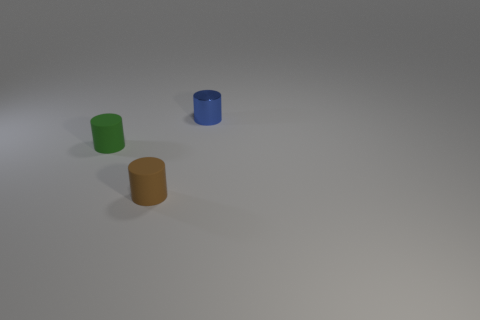Add 2 green cylinders. How many objects exist? 5 Subtract all small rubber cylinders. How many cylinders are left? 1 Subtract all brown cylinders. How many cylinders are left? 2 Subtract 1 cylinders. How many cylinders are left? 2 Subtract all purple cylinders. Subtract all cyan spheres. How many cylinders are left? 3 Subtract all brown cubes. How many brown cylinders are left? 1 Subtract all small shiny things. Subtract all big blue balls. How many objects are left? 2 Add 1 small blue shiny cylinders. How many small blue shiny cylinders are left? 2 Add 1 big blue rubber cubes. How many big blue rubber cubes exist? 1 Subtract 0 green blocks. How many objects are left? 3 